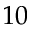Convert formula to latex. <formula><loc_0><loc_0><loc_500><loc_500>1 0</formula> 